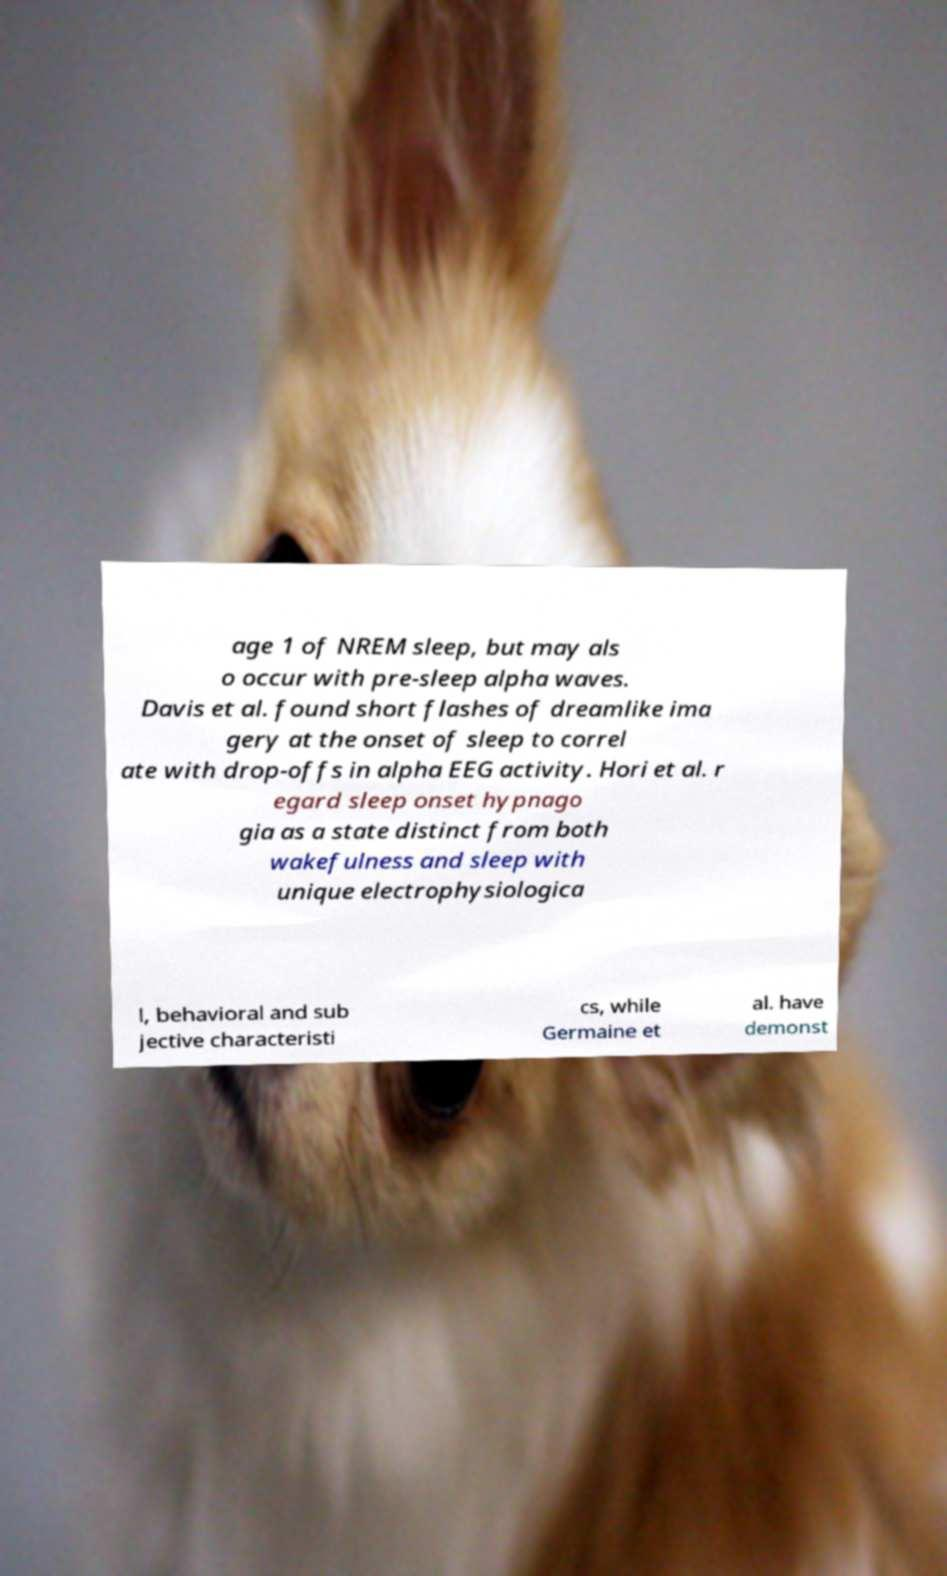Can you accurately transcribe the text from the provided image for me? age 1 of NREM sleep, but may als o occur with pre-sleep alpha waves. Davis et al. found short flashes of dreamlike ima gery at the onset of sleep to correl ate with drop-offs in alpha EEG activity. Hori et al. r egard sleep onset hypnago gia as a state distinct from both wakefulness and sleep with unique electrophysiologica l, behavioral and sub jective characteristi cs, while Germaine et al. have demonst 